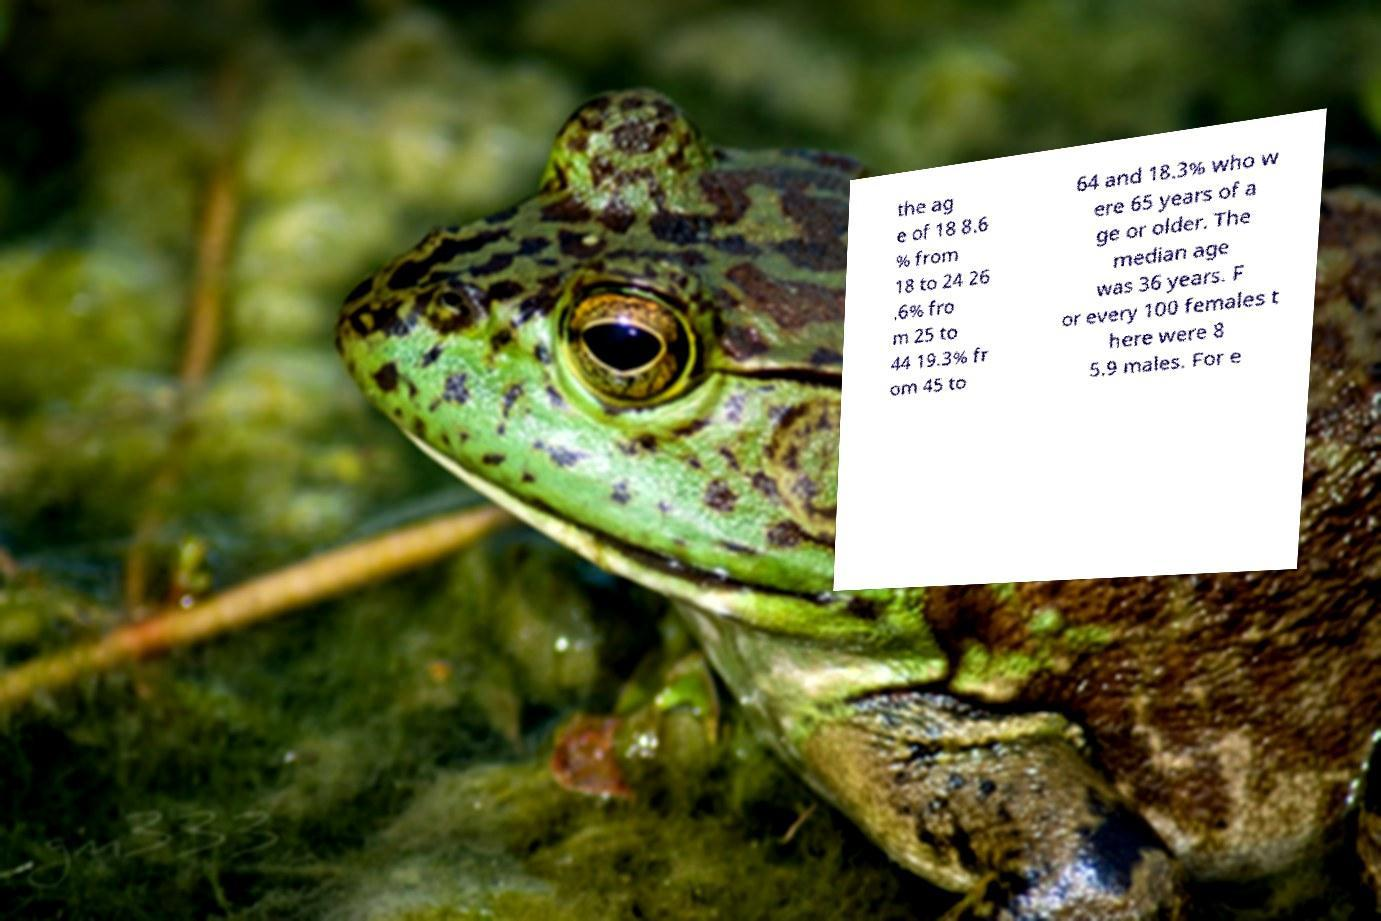I need the written content from this picture converted into text. Can you do that? the ag e of 18 8.6 % from 18 to 24 26 .6% fro m 25 to 44 19.3% fr om 45 to 64 and 18.3% who w ere 65 years of a ge or older. The median age was 36 years. F or every 100 females t here were 8 5.9 males. For e 